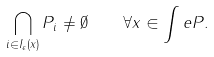Convert formula to latex. <formula><loc_0><loc_0><loc_500><loc_500>\bigcap _ { i \in I _ { \epsilon } ( x ) } P _ { i } \neq \emptyset \quad \forall x \in \int e P .</formula> 